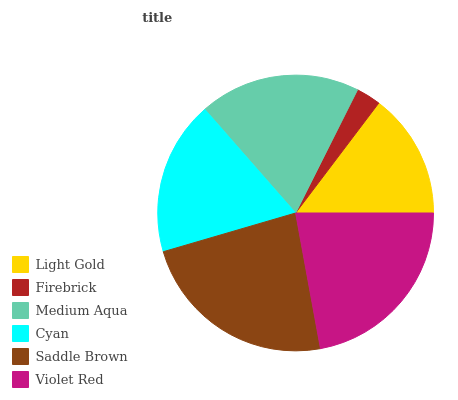Is Firebrick the minimum?
Answer yes or no. Yes. Is Saddle Brown the maximum?
Answer yes or no. Yes. Is Medium Aqua the minimum?
Answer yes or no. No. Is Medium Aqua the maximum?
Answer yes or no. No. Is Medium Aqua greater than Firebrick?
Answer yes or no. Yes. Is Firebrick less than Medium Aqua?
Answer yes or no. Yes. Is Firebrick greater than Medium Aqua?
Answer yes or no. No. Is Medium Aqua less than Firebrick?
Answer yes or no. No. Is Medium Aqua the high median?
Answer yes or no. Yes. Is Cyan the low median?
Answer yes or no. Yes. Is Saddle Brown the high median?
Answer yes or no. No. Is Firebrick the low median?
Answer yes or no. No. 